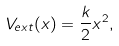<formula> <loc_0><loc_0><loc_500><loc_500>V _ { e x t } ( x ) = \frac { k } { 2 } x ^ { 2 } ,</formula> 